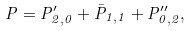Convert formula to latex. <formula><loc_0><loc_0><loc_500><loc_500>P = P ^ { \prime } _ { 2 , 0 } + \bar { P } _ { 1 , 1 } + P ^ { \prime \prime } _ { 0 , 2 } ,</formula> 